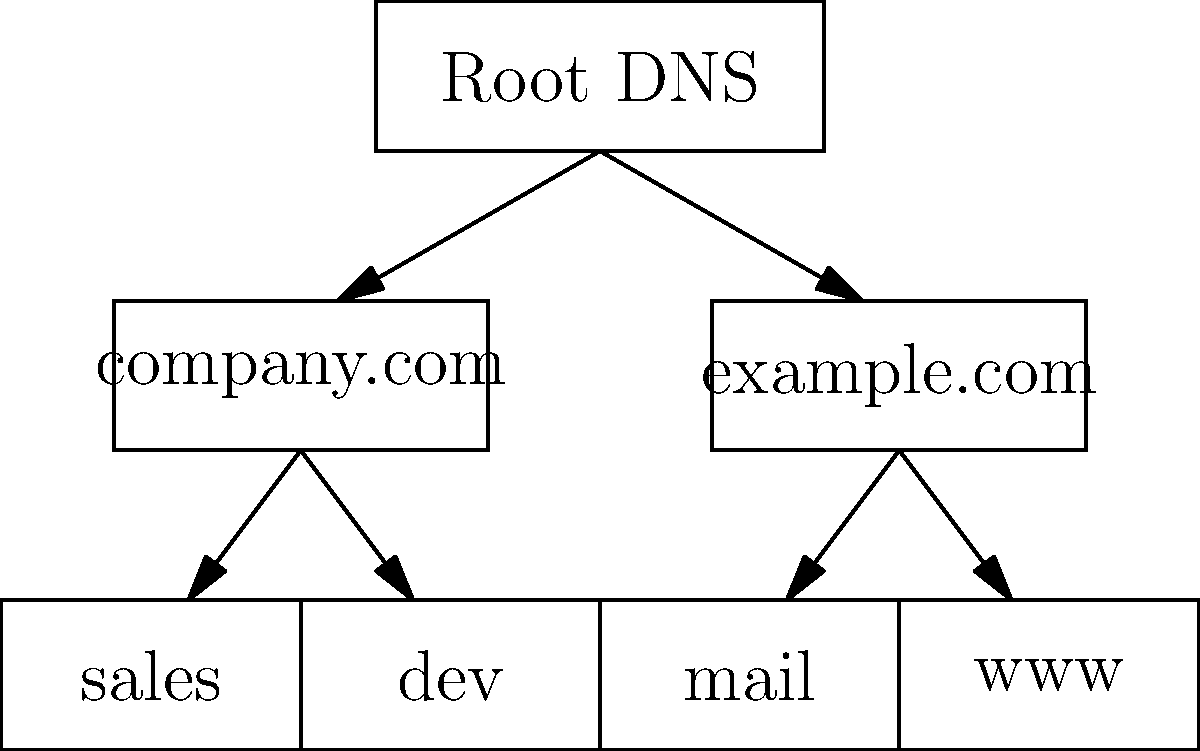In the given hierarchical DNS structure diagram, you need to set up DNS server zones for the "company.com" domain and its subdomains. Which of the following zone configurations in Ubuntu's BIND9 DNS server would correctly represent this structure?

A) A single zone file for "company.com" with all subdomains as records
B) Separate zone files for "company.com" and each subdomain
C) A single zone file for the root DNS, with "company.com" as a subdomain
D) Separate zone files for "company.com" and "example.com" only To correctly set up DNS server zones for the "company.com" domain and its subdomains in Ubuntu's BIND9 DNS server, we need to consider the hierarchical structure shown in the diagram. Let's break down the process:

1. Analyze the diagram:
   - We see a root DNS server at the top
   - Under it, we have two top-level domains: "company.com" and "example.com"
   - "company.com" has two subdomains: "sales" and "dev"

2. Consider DNS zone delegation:
   - Each domain and subdomain can be managed as a separate zone
   - This allows for distributed management and more efficient updates

3. Set up zones in BIND9:
   - Create a zone file for "company.com"
   - Create separate zone files for "sales.company.com" and "dev.company.com"

4. Configure named.conf:
   - Add zone declarations for each zone file created

5. Zone file contents:
   - "company.com" zone file will contain NS records for "sales" and "dev" subdomains
   - "sales.company.com" and "dev.company.com" zone files will contain their respective records

6. Benefits of this approach:
   - Allows for easier management of subdomains
   - Enables delegation of subdomain management if needed
   - Improves performance by allowing separate zone transfers

Therefore, the correct configuration would be separate zone files for "company.com" and each subdomain, which corresponds to option B in the question.
Answer: B) Separate zone files for "company.com" and each subdomain 